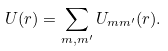Convert formula to latex. <formula><loc_0><loc_0><loc_500><loc_500>U ( { r } ) = \sum _ { m , m ^ { \prime } } U _ { m m ^ { \prime } } ( { r } ) .</formula> 